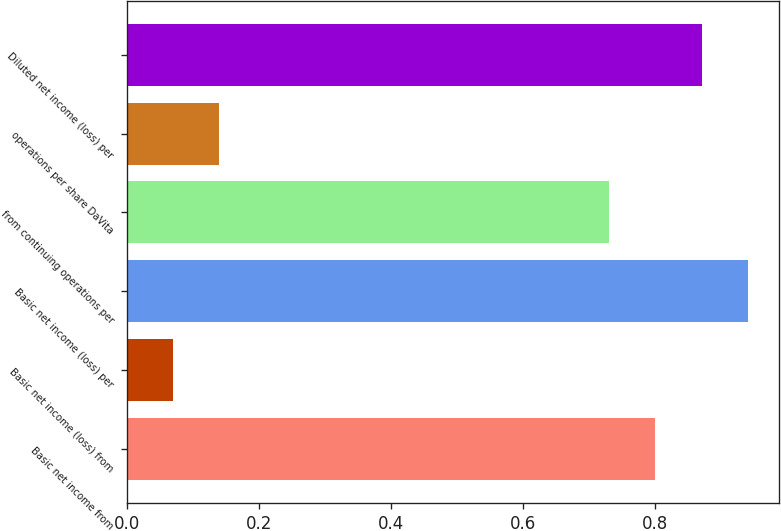<chart> <loc_0><loc_0><loc_500><loc_500><bar_chart><fcel>Basic net income from<fcel>Basic net income (loss) from<fcel>Basic net income (loss) per<fcel>from continuing operations per<fcel>operations per share DaVita<fcel>Diluted net income (loss) per<nl><fcel>0.8<fcel>0.07<fcel>0.94<fcel>0.73<fcel>0.14<fcel>0.87<nl></chart> 